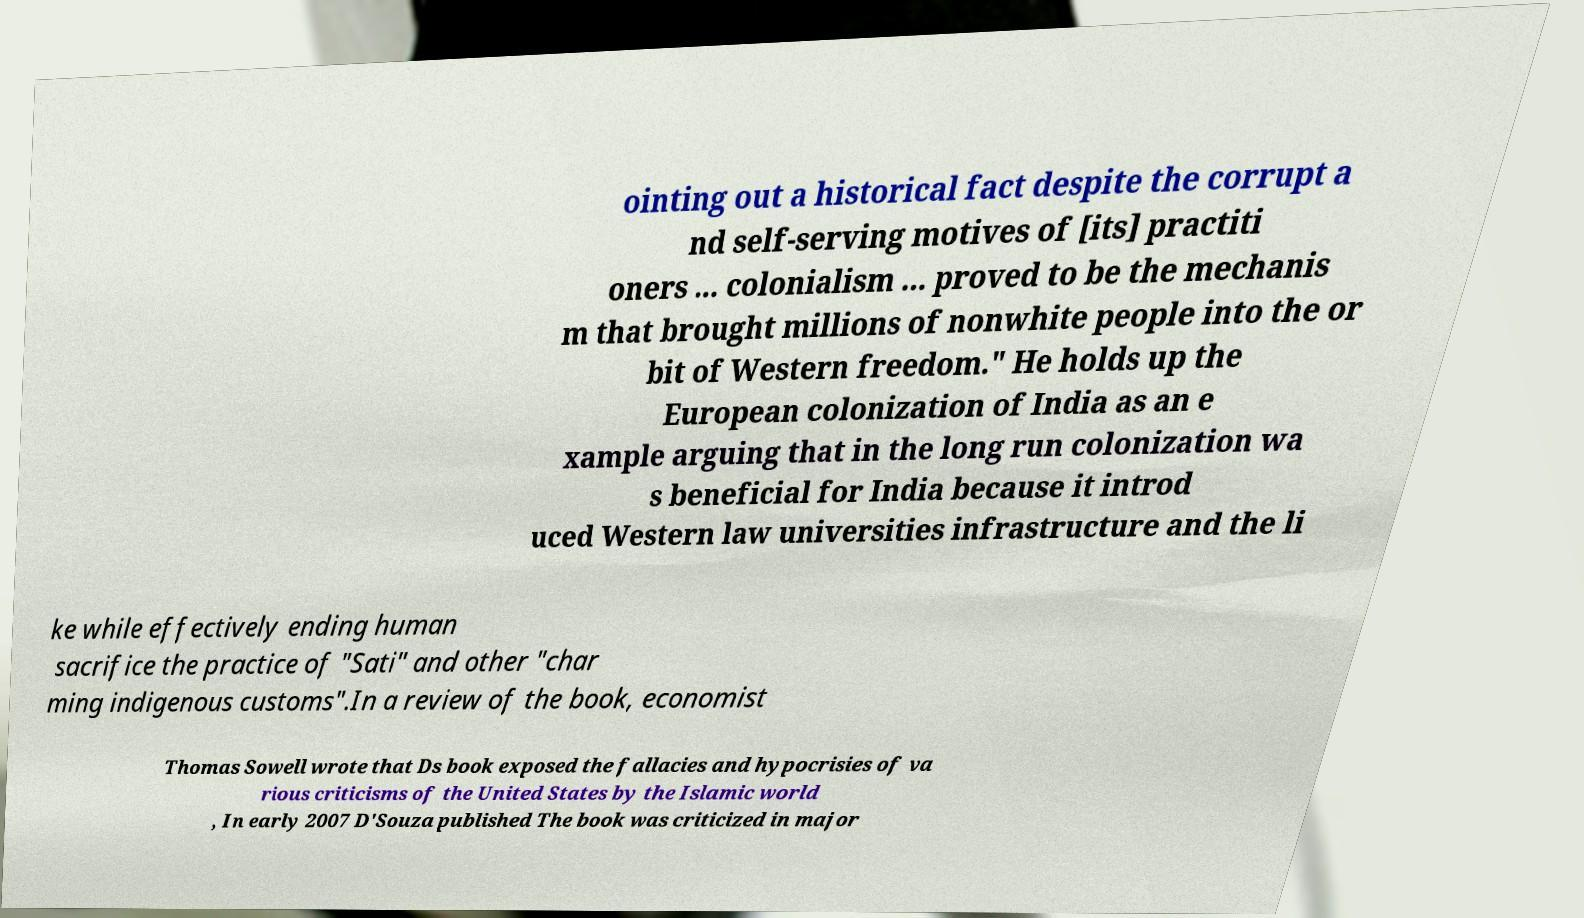Could you assist in decoding the text presented in this image and type it out clearly? ointing out a historical fact despite the corrupt a nd self-serving motives of [its] practiti oners ... colonialism ... proved to be the mechanis m that brought millions of nonwhite people into the or bit of Western freedom." He holds up the European colonization of India as an e xample arguing that in the long run colonization wa s beneficial for India because it introd uced Western law universities infrastructure and the li ke while effectively ending human sacrifice the practice of "Sati" and other "char ming indigenous customs".In a review of the book, economist Thomas Sowell wrote that Ds book exposed the fallacies and hypocrisies of va rious criticisms of the United States by the Islamic world , In early 2007 D'Souza published The book was criticized in major 